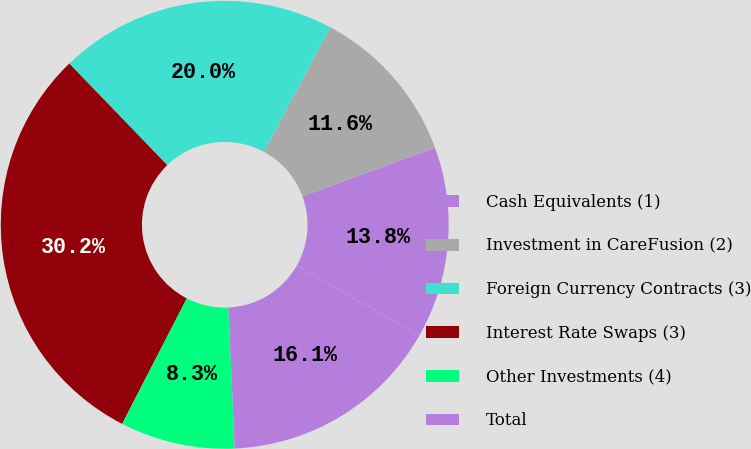Convert chart to OTSL. <chart><loc_0><loc_0><loc_500><loc_500><pie_chart><fcel>Cash Equivalents (1)<fcel>Investment in CareFusion (2)<fcel>Foreign Currency Contracts (3)<fcel>Interest Rate Swaps (3)<fcel>Other Investments (4)<fcel>Total<nl><fcel>13.82%<fcel>11.59%<fcel>20.03%<fcel>30.22%<fcel>8.28%<fcel>16.06%<nl></chart> 